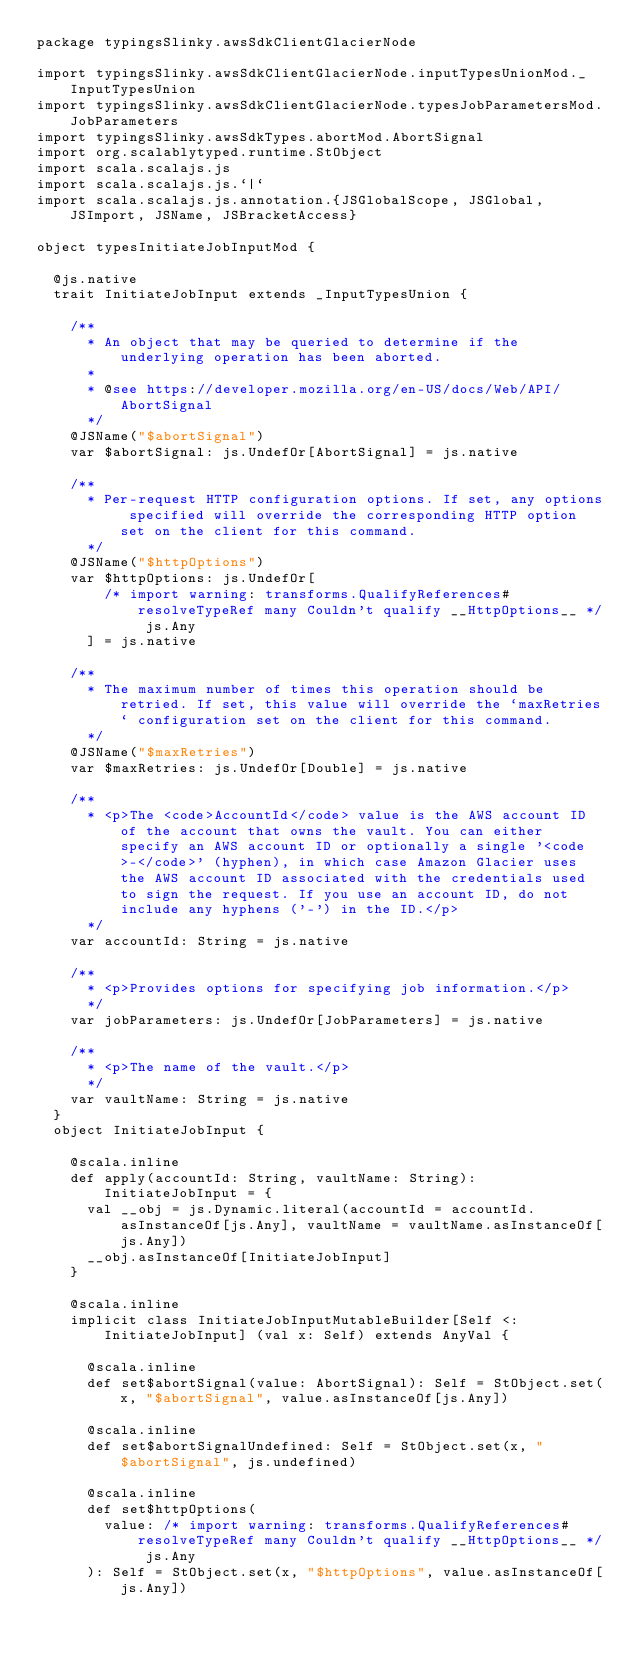<code> <loc_0><loc_0><loc_500><loc_500><_Scala_>package typingsSlinky.awsSdkClientGlacierNode

import typingsSlinky.awsSdkClientGlacierNode.inputTypesUnionMod._InputTypesUnion
import typingsSlinky.awsSdkClientGlacierNode.typesJobParametersMod.JobParameters
import typingsSlinky.awsSdkTypes.abortMod.AbortSignal
import org.scalablytyped.runtime.StObject
import scala.scalajs.js
import scala.scalajs.js.`|`
import scala.scalajs.js.annotation.{JSGlobalScope, JSGlobal, JSImport, JSName, JSBracketAccess}

object typesInitiateJobInputMod {
  
  @js.native
  trait InitiateJobInput extends _InputTypesUnion {
    
    /**
      * An object that may be queried to determine if the underlying operation has been aborted.
      *
      * @see https://developer.mozilla.org/en-US/docs/Web/API/AbortSignal
      */
    @JSName("$abortSignal")
    var $abortSignal: js.UndefOr[AbortSignal] = js.native
    
    /**
      * Per-request HTTP configuration options. If set, any options specified will override the corresponding HTTP option set on the client for this command.
      */
    @JSName("$httpOptions")
    var $httpOptions: js.UndefOr[
        /* import warning: transforms.QualifyReferences#resolveTypeRef many Couldn't qualify __HttpOptions__ */ js.Any
      ] = js.native
    
    /**
      * The maximum number of times this operation should be retried. If set, this value will override the `maxRetries` configuration set on the client for this command.
      */
    @JSName("$maxRetries")
    var $maxRetries: js.UndefOr[Double] = js.native
    
    /**
      * <p>The <code>AccountId</code> value is the AWS account ID of the account that owns the vault. You can either specify an AWS account ID or optionally a single '<code>-</code>' (hyphen), in which case Amazon Glacier uses the AWS account ID associated with the credentials used to sign the request. If you use an account ID, do not include any hyphens ('-') in the ID.</p>
      */
    var accountId: String = js.native
    
    /**
      * <p>Provides options for specifying job information.</p>
      */
    var jobParameters: js.UndefOr[JobParameters] = js.native
    
    /**
      * <p>The name of the vault.</p>
      */
    var vaultName: String = js.native
  }
  object InitiateJobInput {
    
    @scala.inline
    def apply(accountId: String, vaultName: String): InitiateJobInput = {
      val __obj = js.Dynamic.literal(accountId = accountId.asInstanceOf[js.Any], vaultName = vaultName.asInstanceOf[js.Any])
      __obj.asInstanceOf[InitiateJobInput]
    }
    
    @scala.inline
    implicit class InitiateJobInputMutableBuilder[Self <: InitiateJobInput] (val x: Self) extends AnyVal {
      
      @scala.inline
      def set$abortSignal(value: AbortSignal): Self = StObject.set(x, "$abortSignal", value.asInstanceOf[js.Any])
      
      @scala.inline
      def set$abortSignalUndefined: Self = StObject.set(x, "$abortSignal", js.undefined)
      
      @scala.inline
      def set$httpOptions(
        value: /* import warning: transforms.QualifyReferences#resolveTypeRef many Couldn't qualify __HttpOptions__ */ js.Any
      ): Self = StObject.set(x, "$httpOptions", value.asInstanceOf[js.Any])
      </code> 